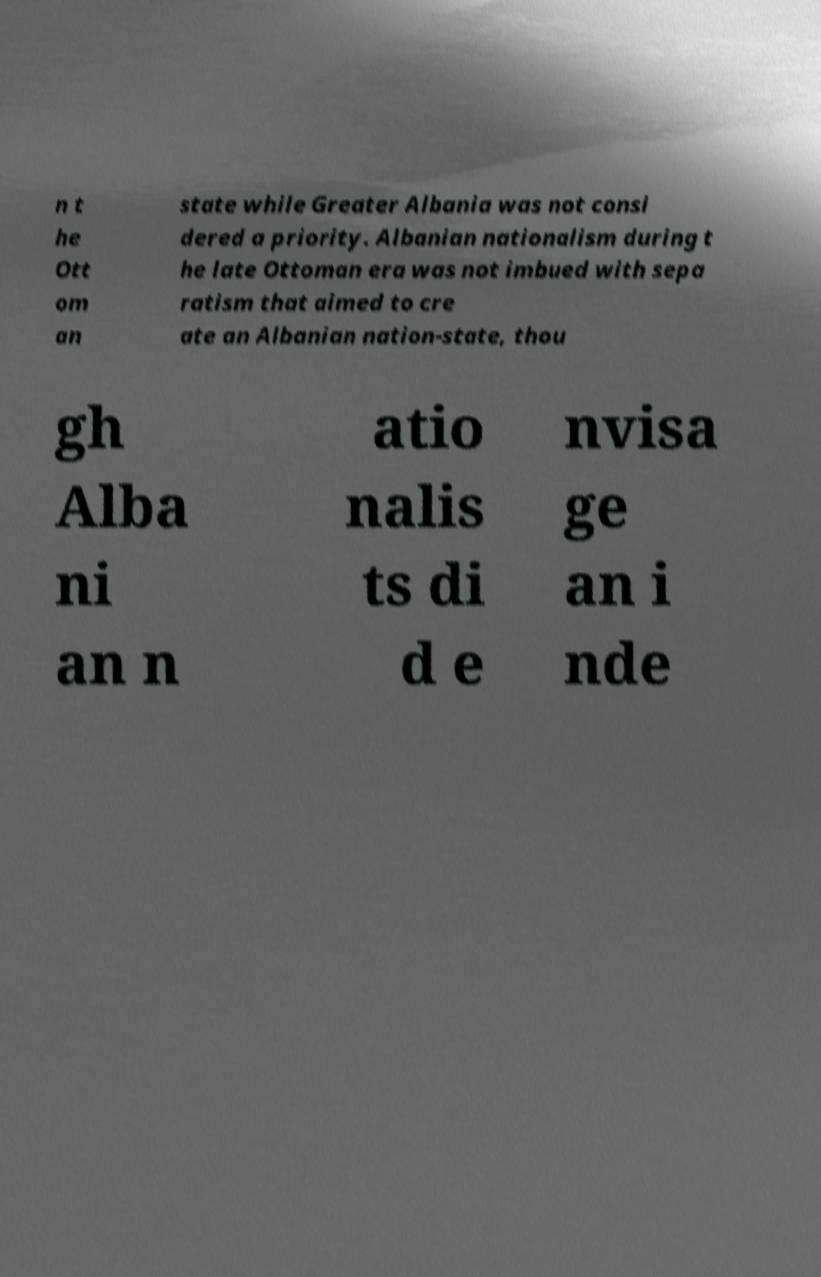Could you assist in decoding the text presented in this image and type it out clearly? n t he Ott om an state while Greater Albania was not consi dered a priority. Albanian nationalism during t he late Ottoman era was not imbued with sepa ratism that aimed to cre ate an Albanian nation-state, thou gh Alba ni an n atio nalis ts di d e nvisa ge an i nde 